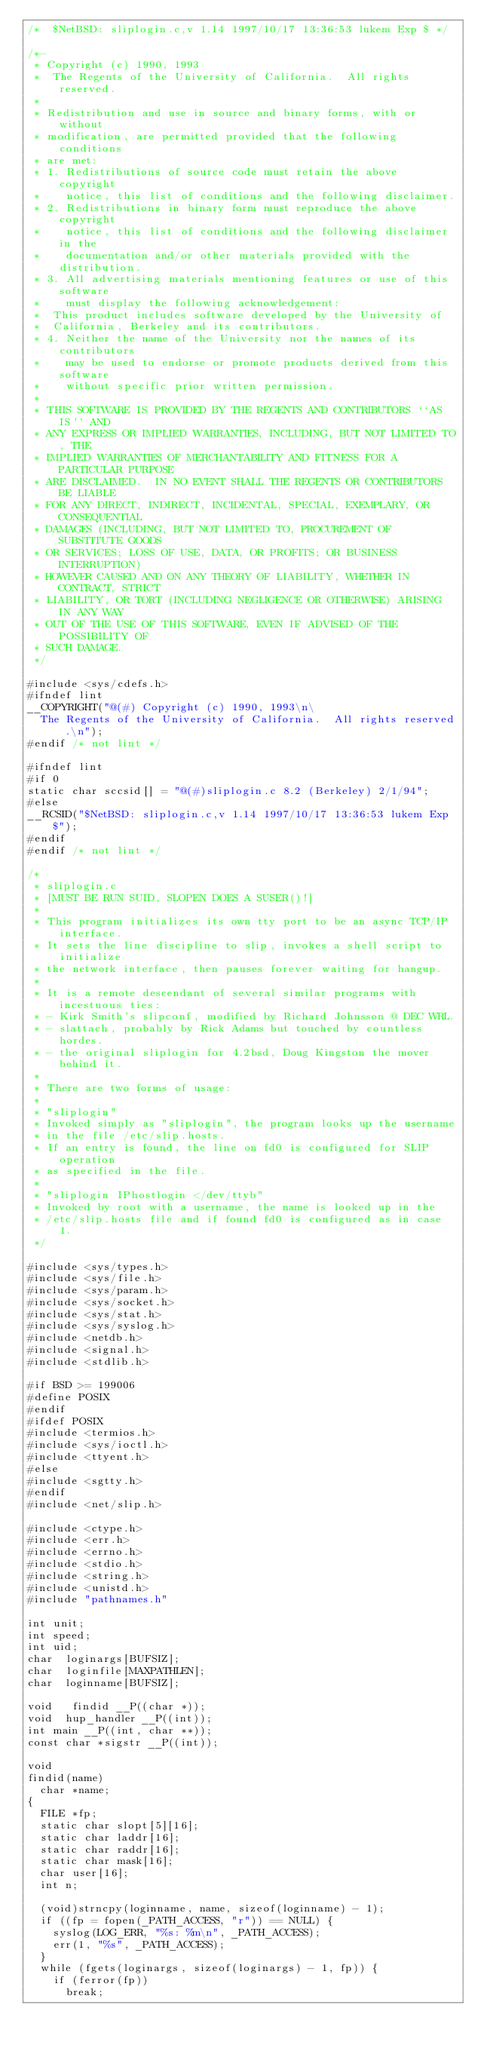Convert code to text. <code><loc_0><loc_0><loc_500><loc_500><_C_>/*	$NetBSD: sliplogin.c,v 1.14 1997/10/17 13:36:53 lukem Exp $	*/

/*-
 * Copyright (c) 1990, 1993
 *	The Regents of the University of California.  All rights reserved.
 *
 * Redistribution and use in source and binary forms, with or without
 * modification, are permitted provided that the following conditions
 * are met:
 * 1. Redistributions of source code must retain the above copyright
 *    notice, this list of conditions and the following disclaimer.
 * 2. Redistributions in binary form must reproduce the above copyright
 *    notice, this list of conditions and the following disclaimer in the
 *    documentation and/or other materials provided with the distribution.
 * 3. All advertising materials mentioning features or use of this software
 *    must display the following acknowledgement:
 *	This product includes software developed by the University of
 *	California, Berkeley and its contributors.
 * 4. Neither the name of the University nor the names of its contributors
 *    may be used to endorse or promote products derived from this software
 *    without specific prior written permission.
 *
 * THIS SOFTWARE IS PROVIDED BY THE REGENTS AND CONTRIBUTORS ``AS IS'' AND
 * ANY EXPRESS OR IMPLIED WARRANTIES, INCLUDING, BUT NOT LIMITED TO, THE
 * IMPLIED WARRANTIES OF MERCHANTABILITY AND FITNESS FOR A PARTICULAR PURPOSE
 * ARE DISCLAIMED.  IN NO EVENT SHALL THE REGENTS OR CONTRIBUTORS BE LIABLE
 * FOR ANY DIRECT, INDIRECT, INCIDENTAL, SPECIAL, EXEMPLARY, OR CONSEQUENTIAL
 * DAMAGES (INCLUDING, BUT NOT LIMITED TO, PROCUREMENT OF SUBSTITUTE GOODS
 * OR SERVICES; LOSS OF USE, DATA, OR PROFITS; OR BUSINESS INTERRUPTION)
 * HOWEVER CAUSED AND ON ANY THEORY OF LIABILITY, WHETHER IN CONTRACT, STRICT
 * LIABILITY, OR TORT (INCLUDING NEGLIGENCE OR OTHERWISE) ARISING IN ANY WAY
 * OUT OF THE USE OF THIS SOFTWARE, EVEN IF ADVISED OF THE POSSIBILITY OF
 * SUCH DAMAGE.
 */

#include <sys/cdefs.h>
#ifndef lint
__COPYRIGHT("@(#) Copyright (c) 1990, 1993\n\
	The Regents of the University of California.  All rights reserved.\n");
#endif /* not lint */

#ifndef lint
#if 0
static char sccsid[] = "@(#)sliplogin.c	8.2 (Berkeley) 2/1/94";
#else
__RCSID("$NetBSD: sliplogin.c,v 1.14 1997/10/17 13:36:53 lukem Exp $");
#endif
#endif /* not lint */

/*
 * sliplogin.c
 * [MUST BE RUN SUID, SLOPEN DOES A SUSER()!]
 *
 * This program initializes its own tty port to be an async TCP/IP interface.
 * It sets the line discipline to slip, invokes a shell script to initialize
 * the network interface, then pauses forever waiting for hangup.
 *
 * It is a remote descendant of several similar programs with incestuous ties:
 * - Kirk Smith's slipconf, modified by Richard Johnsson @ DEC WRL.
 * - slattach, probably by Rick Adams but touched by countless hordes.
 * - the original sliplogin for 4.2bsd, Doug Kingston the mover behind it.
 *
 * There are two forms of usage:
 *
 * "sliplogin"
 * Invoked simply as "sliplogin", the program looks up the username
 * in the file /etc/slip.hosts.
 * If an entry is found, the line on fd0 is configured for SLIP operation
 * as specified in the file.
 *
 * "sliplogin IPhostlogin </dev/ttyb"
 * Invoked by root with a username, the name is looked up in the
 * /etc/slip.hosts file and if found fd0 is configured as in case 1.
 */

#include <sys/types.h>
#include <sys/file.h>
#include <sys/param.h>
#include <sys/socket.h>
#include <sys/stat.h>
#include <sys/syslog.h>
#include <netdb.h>
#include <signal.h>
#include <stdlib.h>

#if BSD >= 199006
#define POSIX
#endif
#ifdef POSIX
#include <termios.h>
#include <sys/ioctl.h>
#include <ttyent.h>
#else
#include <sgtty.h>
#endif
#include <net/slip.h>

#include <ctype.h>
#include <err.h>
#include <errno.h>
#include <stdio.h>
#include <string.h>
#include <unistd.h>
#include "pathnames.h"

int	unit;
int	speed;
int	uid;
char	loginargs[BUFSIZ];
char	loginfile[MAXPATHLEN];
char	loginname[BUFSIZ];

void	 findid __P((char *));
void	hup_handler __P((int));
int	main __P((int, char **));
const char *sigstr __P((int));

void
findid(name)
	char *name;
{
	FILE *fp;
	static char slopt[5][16];
	static char laddr[16];
	static char raddr[16];
	static char mask[16];
	char user[16];
	int n;

	(void)strncpy(loginname, name, sizeof(loginname) - 1);
	if ((fp = fopen(_PATH_ACCESS, "r")) == NULL) {
		syslog(LOG_ERR, "%s: %m\n", _PATH_ACCESS);
		err(1, "%s", _PATH_ACCESS);
	}
	while (fgets(loginargs, sizeof(loginargs) - 1, fp)) {
		if (ferror(fp))
			break;</code> 